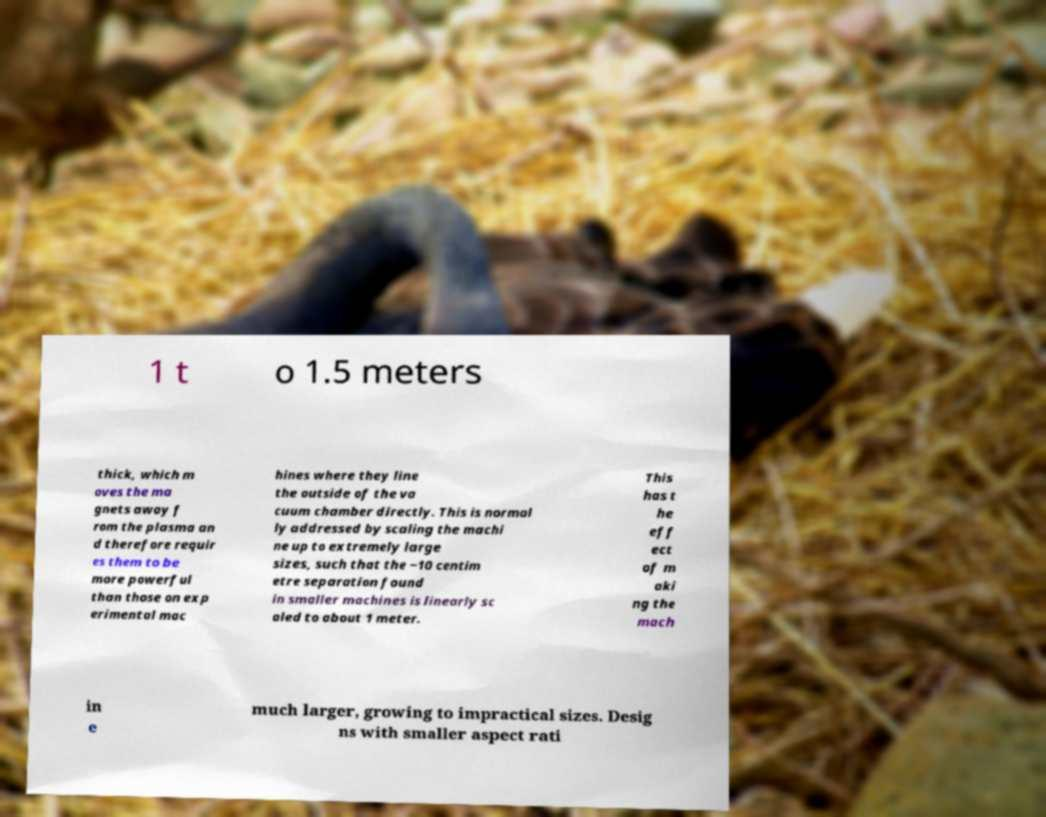What messages or text are displayed in this image? I need them in a readable, typed format. 1 t o 1.5 meters thick, which m oves the ma gnets away f rom the plasma an d therefore requir es them to be more powerful than those on exp erimental mac hines where they line the outside of the va cuum chamber directly. This is normal ly addressed by scaling the machi ne up to extremely large sizes, such that the ~10 centim etre separation found in smaller machines is linearly sc aled to about 1 meter. This has t he eff ect of m aki ng the mach in e much larger, growing to impractical sizes. Desig ns with smaller aspect rati 